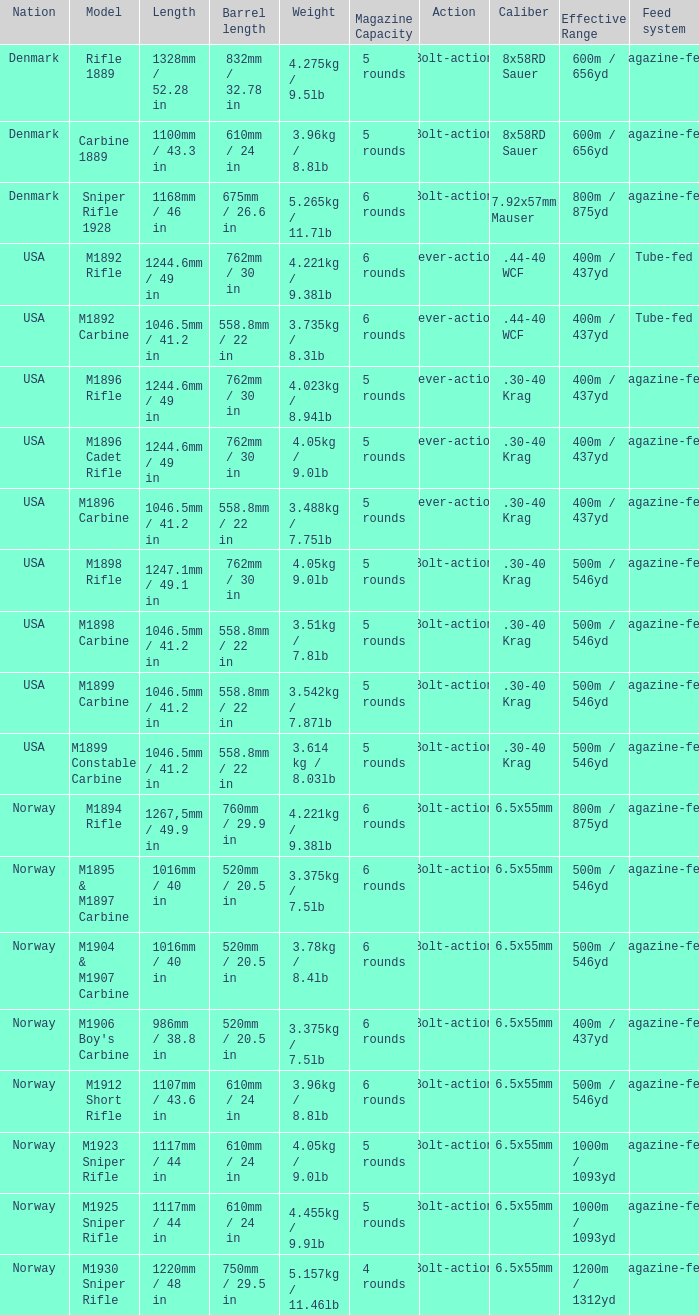What is Length, when Barrel Length is 750mm / 29.5 in? 1220mm / 48 in. 